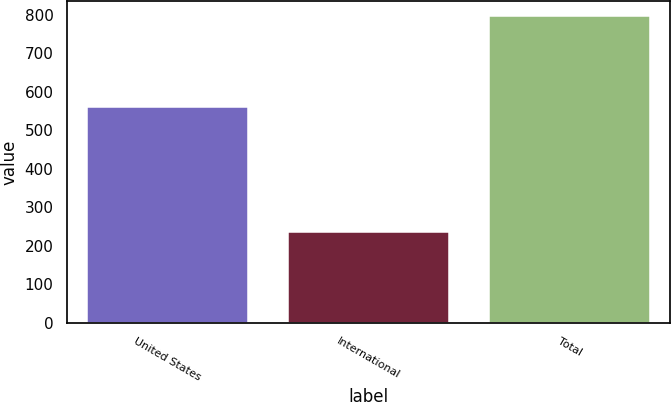<chart> <loc_0><loc_0><loc_500><loc_500><bar_chart><fcel>United States<fcel>International<fcel>Total<nl><fcel>560.7<fcel>236<fcel>796.7<nl></chart> 